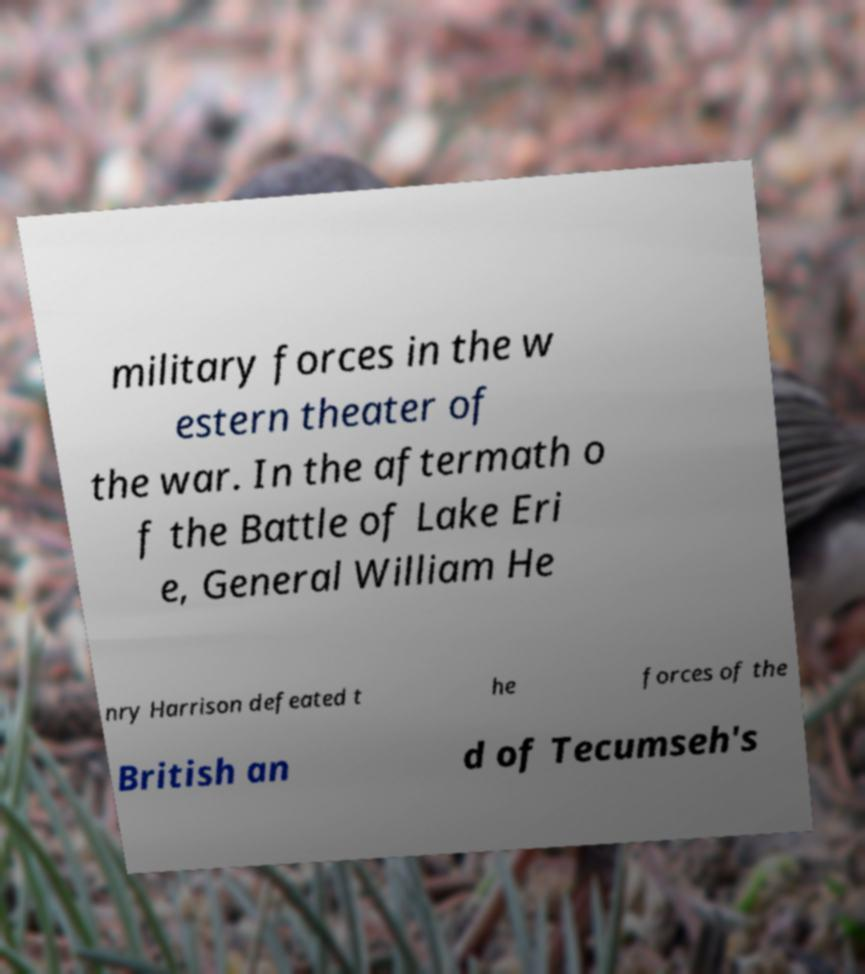Please read and relay the text visible in this image. What does it say? military forces in the w estern theater of the war. In the aftermath o f the Battle of Lake Eri e, General William He nry Harrison defeated t he forces of the British an d of Tecumseh's 